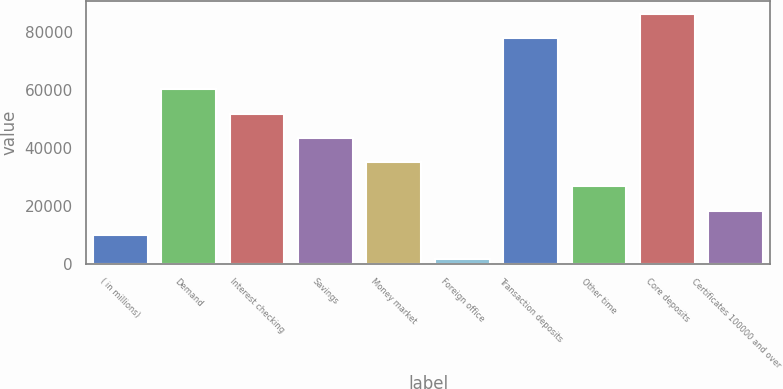Convert chart. <chart><loc_0><loc_0><loc_500><loc_500><bar_chart><fcel>( in millions)<fcel>Demand<fcel>Interest checking<fcel>Savings<fcel>Money market<fcel>Foreign office<fcel>Transaction deposits<fcel>Other time<fcel>Core deposits<fcel>Certificates 100000 and over<nl><fcel>9930.3<fcel>60344.1<fcel>51941.8<fcel>43539.5<fcel>35137.2<fcel>1528<fcel>78116<fcel>26734.9<fcel>86518.3<fcel>18332.6<nl></chart> 